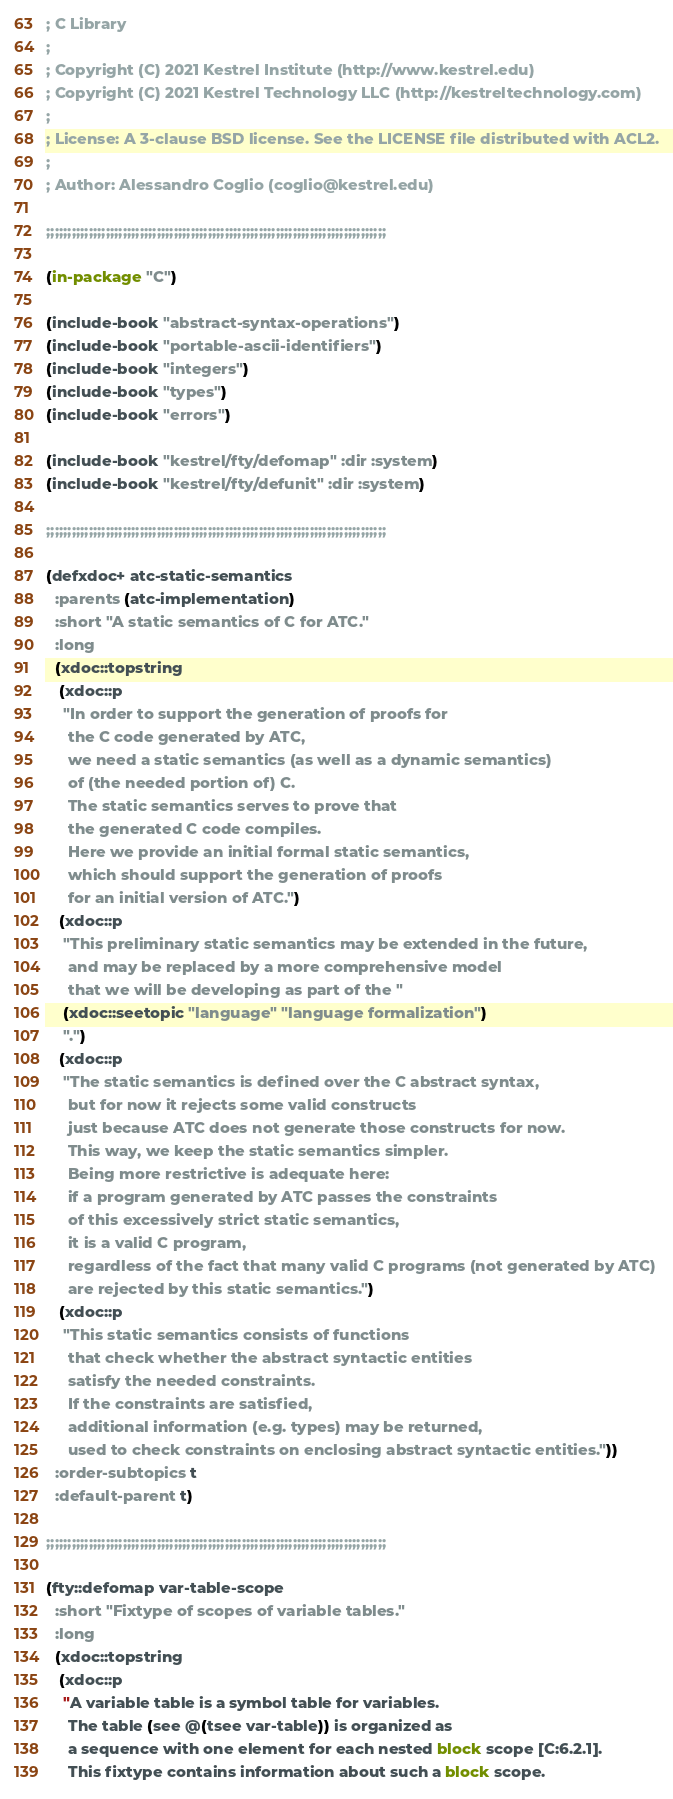<code> <loc_0><loc_0><loc_500><loc_500><_Lisp_>; C Library
;
; Copyright (C) 2021 Kestrel Institute (http://www.kestrel.edu)
; Copyright (C) 2021 Kestrel Technology LLC (http://kestreltechnology.com)
;
; License: A 3-clause BSD license. See the LICENSE file distributed with ACL2.
;
; Author: Alessandro Coglio (coglio@kestrel.edu)

;;;;;;;;;;;;;;;;;;;;;;;;;;;;;;;;;;;;;;;;;;;;;;;;;;;;;;;;;;;;;;;;;;;;;;;;;;;;;;;;

(in-package "C")

(include-book "abstract-syntax-operations")
(include-book "portable-ascii-identifiers")
(include-book "integers")
(include-book "types")
(include-book "errors")

(include-book "kestrel/fty/defomap" :dir :system)
(include-book "kestrel/fty/defunit" :dir :system)

;;;;;;;;;;;;;;;;;;;;;;;;;;;;;;;;;;;;;;;;;;;;;;;;;;;;;;;;;;;;;;;;;;;;;;;;;;;;;;;;

(defxdoc+ atc-static-semantics
  :parents (atc-implementation)
  :short "A static semantics of C for ATC."
  :long
  (xdoc::topstring
   (xdoc::p
    "In order to support the generation of proofs for
     the C code generated by ATC,
     we need a static semantics (as well as a dynamic semantics)
     of (the needed portion of) C.
     The static semantics serves to prove that
     the generated C code compiles.
     Here we provide an initial formal static semantics,
     which should support the generation of proofs
     for an initial version of ATC.")
   (xdoc::p
    "This preliminary static semantics may be extended in the future,
     and may be replaced by a more comprehensive model
     that we will be developing as part of the "
    (xdoc::seetopic "language" "language formalization")
    ".")
   (xdoc::p
    "The static semantics is defined over the C abstract syntax,
     but for now it rejects some valid constructs
     just because ATC does not generate those constructs for now.
     This way, we keep the static semantics simpler.
     Being more restrictive is adequate here:
     if a program generated by ATC passes the constraints
     of this excessively strict static semantics,
     it is a valid C program,
     regardless of the fact that many valid C programs (not generated by ATC)
     are rejected by this static semantics.")
   (xdoc::p
    "This static semantics consists of functions
     that check whether the abstract syntactic entities
     satisfy the needed constraints.
     If the constraints are satisfied,
     additional information (e.g. types) may be returned,
     used to check constraints on enclosing abstract syntactic entities."))
  :order-subtopics t
  :default-parent t)

;;;;;;;;;;;;;;;;;;;;;;;;;;;;;;;;;;;;;;;;;;;;;;;;;;;;;;;;;;;;;;;;;;;;;;;;;;;;;;;;

(fty::defomap var-table-scope
  :short "Fixtype of scopes of variable tables."
  :long
  (xdoc::topstring
   (xdoc::p
    "A variable table is a symbol table for variables.
     The table (see @(tsee var-table)) is organized as
     a sequence with one element for each nested block scope [C:6.2.1].
     This fixtype contains information about such a block scope.</code> 